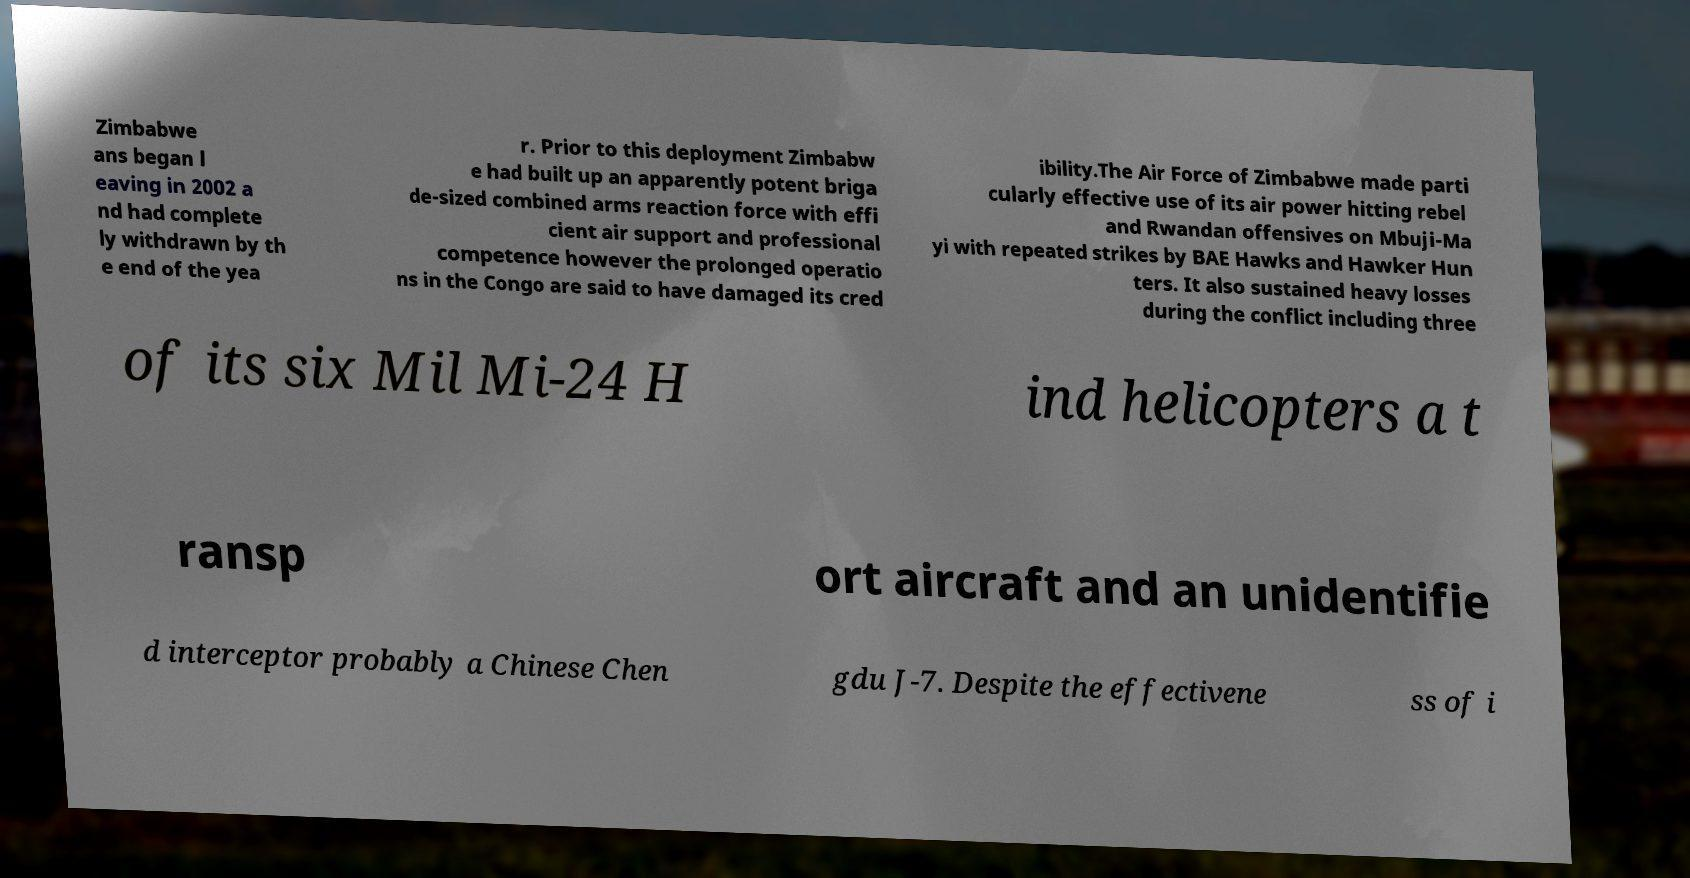There's text embedded in this image that I need extracted. Can you transcribe it verbatim? Zimbabwe ans began l eaving in 2002 a nd had complete ly withdrawn by th e end of the yea r. Prior to this deployment Zimbabw e had built up an apparently potent briga de-sized combined arms reaction force with effi cient air support and professional competence however the prolonged operatio ns in the Congo are said to have damaged its cred ibility.The Air Force of Zimbabwe made parti cularly effective use of its air power hitting rebel and Rwandan offensives on Mbuji-Ma yi with repeated strikes by BAE Hawks and Hawker Hun ters. It also sustained heavy losses during the conflict including three of its six Mil Mi-24 H ind helicopters a t ransp ort aircraft and an unidentifie d interceptor probably a Chinese Chen gdu J-7. Despite the effectivene ss of i 